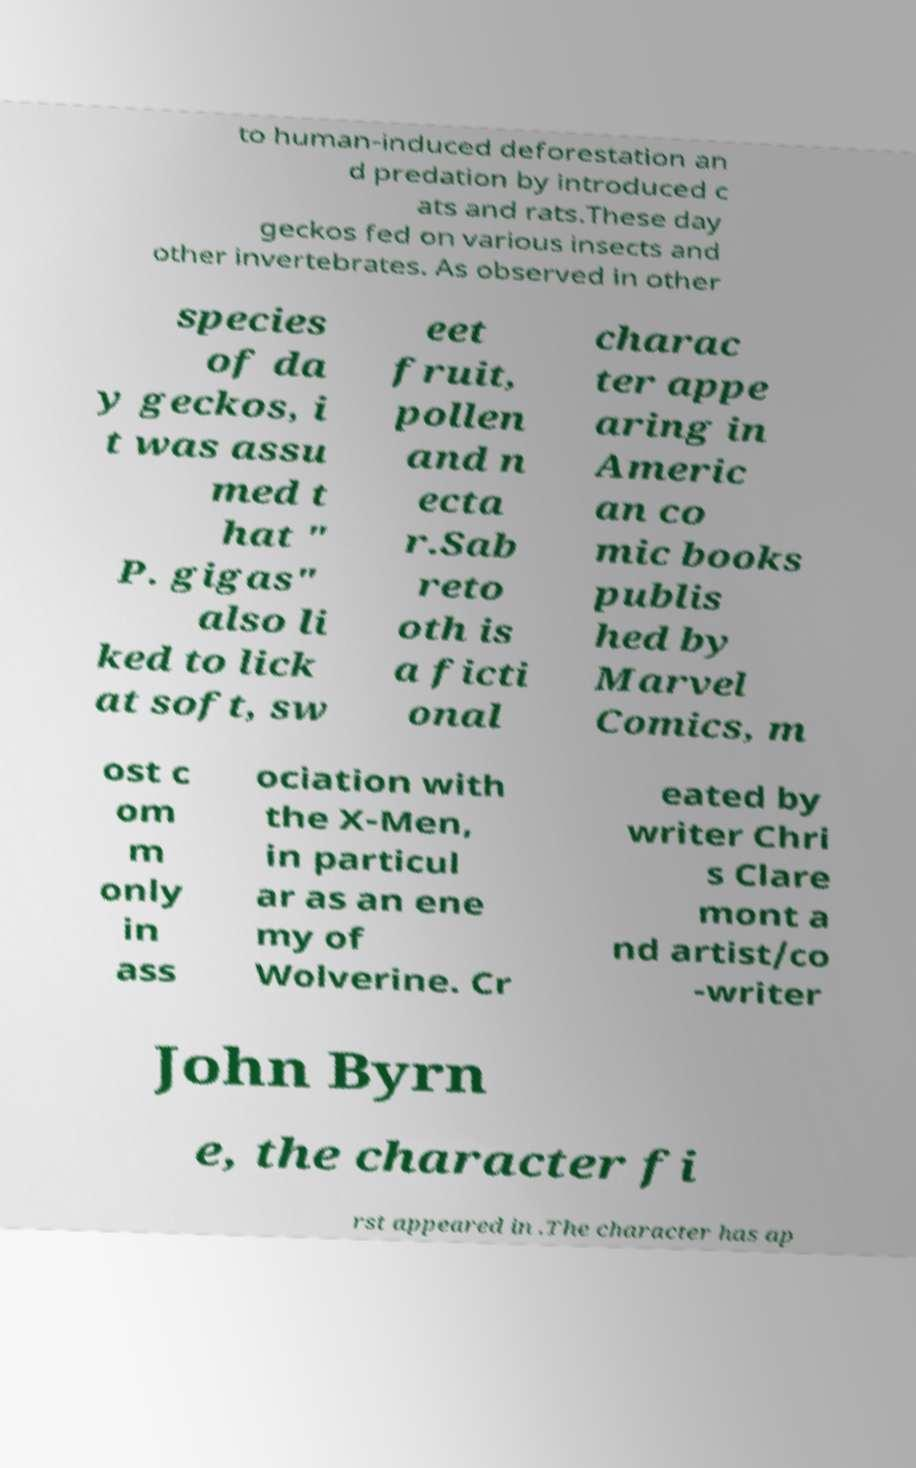There's text embedded in this image that I need extracted. Can you transcribe it verbatim? to human-induced deforestation an d predation by introduced c ats and rats.These day geckos fed on various insects and other invertebrates. As observed in other species of da y geckos, i t was assu med t hat " P. gigas" also li ked to lick at soft, sw eet fruit, pollen and n ecta r.Sab reto oth is a ficti onal charac ter appe aring in Americ an co mic books publis hed by Marvel Comics, m ost c om m only in ass ociation with the X-Men, in particul ar as an ene my of Wolverine. Cr eated by writer Chri s Clare mont a nd artist/co -writer John Byrn e, the character fi rst appeared in .The character has ap 